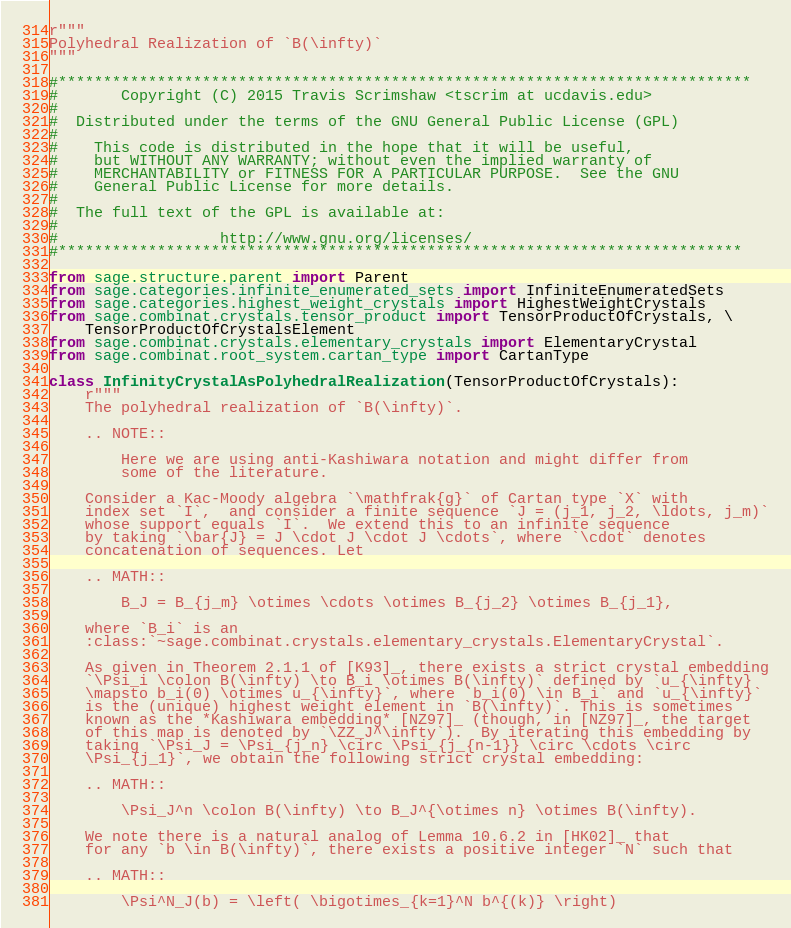Convert code to text. <code><loc_0><loc_0><loc_500><loc_500><_Python_>r"""
Polyhedral Realization of `B(\infty)`
"""

#*****************************************************************************
#       Copyright (C) 2015 Travis Scrimshaw <tscrim at ucdavis.edu>
#
#  Distributed under the terms of the GNU General Public License (GPL)
#
#    This code is distributed in the hope that it will be useful,
#    but WITHOUT ANY WARRANTY; without even the implied warranty of
#    MERCHANTABILITY or FITNESS FOR A PARTICULAR PURPOSE.  See the GNU
#    General Public License for more details.
#
#  The full text of the GPL is available at:
#
#                  http://www.gnu.org/licenses/
#****************************************************************************

from sage.structure.parent import Parent
from sage.categories.infinite_enumerated_sets import InfiniteEnumeratedSets
from sage.categories.highest_weight_crystals import HighestWeightCrystals
from sage.combinat.crystals.tensor_product import TensorProductOfCrystals, \
    TensorProductOfCrystalsElement
from sage.combinat.crystals.elementary_crystals import ElementaryCrystal
from sage.combinat.root_system.cartan_type import CartanType

class InfinityCrystalAsPolyhedralRealization(TensorProductOfCrystals):
    r"""
    The polyhedral realization of `B(\infty)`.

    .. NOTE::

        Here we are using anti-Kashiwara notation and might differ from
        some of the literature.

    Consider a Kac-Moody algebra `\mathfrak{g}` of Cartan type `X` with
    index set `I`,  and consider a finite sequence `J = (j_1, j_2, \ldots, j_m)`
    whose support equals `I`.  We extend this to an infinite sequence
    by taking `\bar{J} = J \cdot J \cdot J \cdots`, where `\cdot` denotes
    concatenation of sequences. Let

    .. MATH::

        B_J = B_{j_m} \otimes \cdots \otimes B_{j_2} \otimes B_{j_1},

    where `B_i` is an
    :class:`~sage.combinat.crystals.elementary_crystals.ElementaryCrystal`.

    As given in Theorem 2.1.1 of [K93]_, there exists a strict crystal embedding
    `\Psi_i \colon B(\infty) \to B_i \otimes B(\infty)` defined by `u_{\infty}
    \mapsto b_i(0) \otimes u_{\infty}`, where `b_i(0) \in B_i` and `u_{\infty}`
    is the (unique) highest weight element in `B(\infty)`. This is sometimes
    known as the *Kashiwara embedding* [NZ97]_ (though, in [NZ97]_, the target
    of this map is denoted by `\ZZ_J^\infty`).  By iterating this embedding by
    taking `\Psi_J = \Psi_{j_n} \circ \Psi_{j_{n-1}} \circ \cdots \circ
    \Psi_{j_1}`, we obtain the following strict crystal embedding:

    .. MATH::

        \Psi_J^n \colon B(\infty) \to B_J^{\otimes n} \otimes B(\infty).

    We note there is a natural analog of Lemma 10.6.2 in [HK02]_ that
    for any `b \in B(\infty)`, there exists a positive integer `N` such that

    .. MATH::

        \Psi^N_J(b) = \left( \bigotimes_{k=1}^N b^{(k)} \right)</code> 